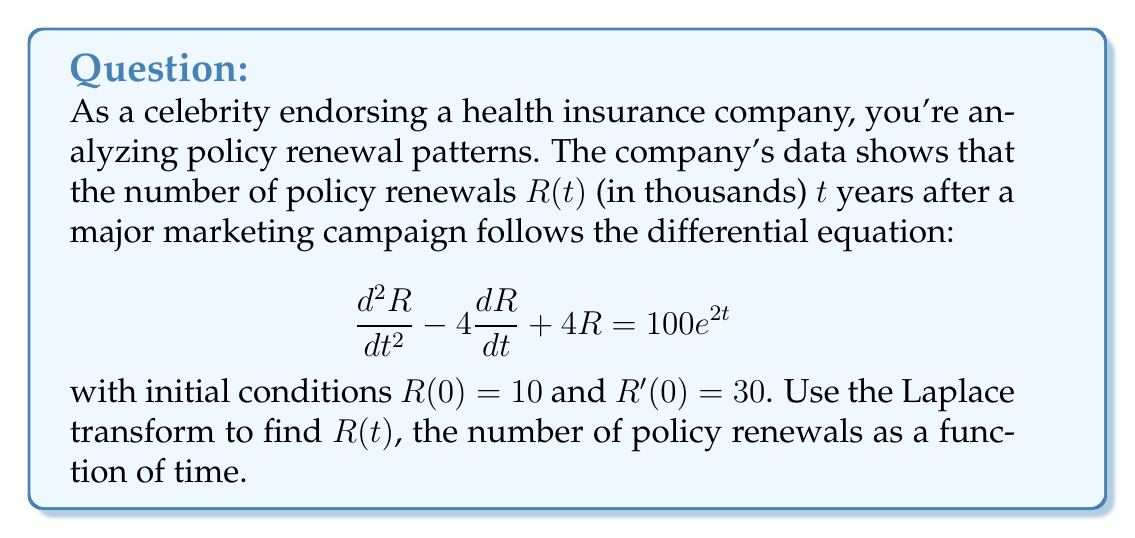What is the answer to this math problem? Let's solve this step-by-step using the Laplace transform:

1) Take the Laplace transform of both sides of the equation:
   $$\mathcal{L}\left\{\frac{d^2R}{dt^2} - 4\frac{dR}{dt} + 4R\right\} = \mathcal{L}\{100e^{2t}\}$$

2) Using Laplace transform properties:
   $$s^2R(s) - sR(0) - R'(0) - 4[sR(s) - R(0)] + 4R(s) = \frac{100}{s-2}$$

3) Substitute the initial conditions $R(0) = 10$ and $R'(0) = 30$:
   $$s^2R(s) - 10s - 30 - 4sR(s) + 40 + 4R(s) = \frac{100}{s-2}$$

4) Simplify:
   $$(s^2 - 4s + 4)R(s) = \frac{100}{s-2} + 10s + 30 - 40$$
   $$(s^2 - 4s + 4)R(s) = \frac{100}{s-2} + 10s - 10$$

5) Solve for $R(s)$:
   $$R(s) = \frac{100}{(s-2)(s^2-4s+4)} + \frac{10s-10}{s^2-4s+4}$$

6) Decompose into partial fractions:
   $$R(s) = \frac{25}{s-2} + \frac{5}{(s-2)^2} + \frac{10s-10}{(s-2)^2}$$

7) Take the inverse Laplace transform:
   $$R(t) = 25e^{2t} + 5te^{2t} + (10t-10)e^{2t}$$

8) Simplify:
   $$R(t) = (15t + 15)e^{2t}$$

This gives us the function for the number of policy renewals over time.
Answer: $R(t) = (15t + 15)e^{2t}$ 